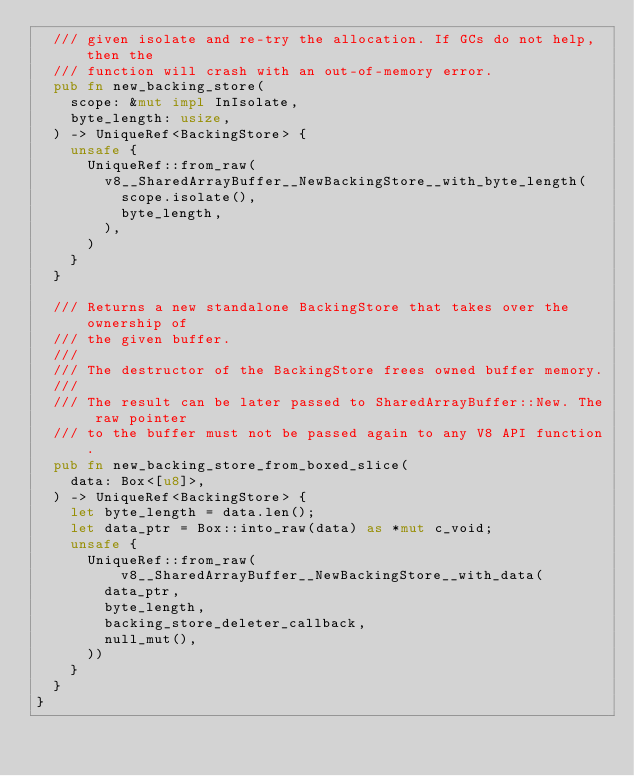Convert code to text. <code><loc_0><loc_0><loc_500><loc_500><_Rust_>  /// given isolate and re-try the allocation. If GCs do not help, then the
  /// function will crash with an out-of-memory error.
  pub fn new_backing_store(
    scope: &mut impl InIsolate,
    byte_length: usize,
  ) -> UniqueRef<BackingStore> {
    unsafe {
      UniqueRef::from_raw(
        v8__SharedArrayBuffer__NewBackingStore__with_byte_length(
          scope.isolate(),
          byte_length,
        ),
      )
    }
  }

  /// Returns a new standalone BackingStore that takes over the ownership of
  /// the given buffer.
  ///
  /// The destructor of the BackingStore frees owned buffer memory.
  ///
  /// The result can be later passed to SharedArrayBuffer::New. The raw pointer
  /// to the buffer must not be passed again to any V8 API function.
  pub fn new_backing_store_from_boxed_slice(
    data: Box<[u8]>,
  ) -> UniqueRef<BackingStore> {
    let byte_length = data.len();
    let data_ptr = Box::into_raw(data) as *mut c_void;
    unsafe {
      UniqueRef::from_raw(v8__SharedArrayBuffer__NewBackingStore__with_data(
        data_ptr,
        byte_length,
        backing_store_deleter_callback,
        null_mut(),
      ))
    }
  }
}
</code> 